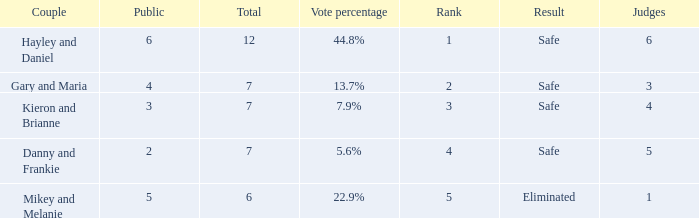How many judges were there for the eliminated couple?  1.0. 